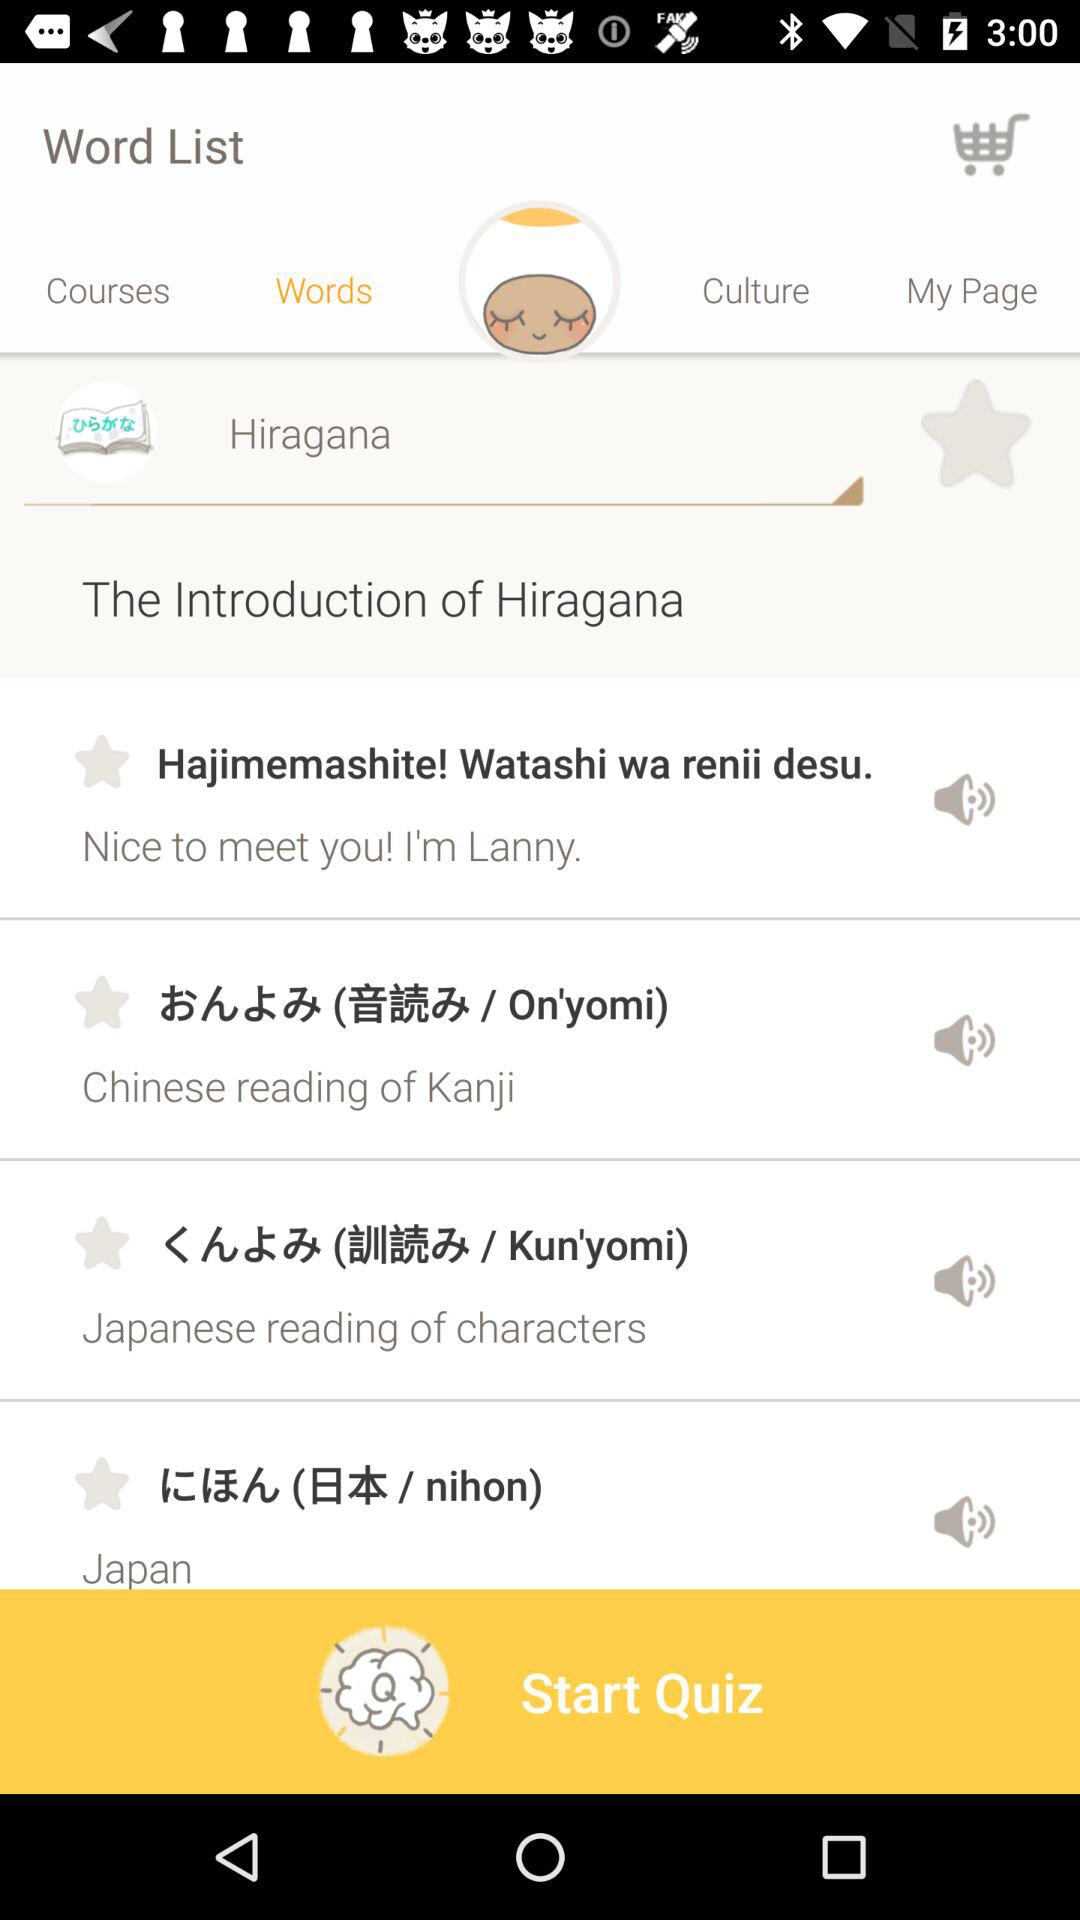What is the application name? The application name is "Eggbun". 